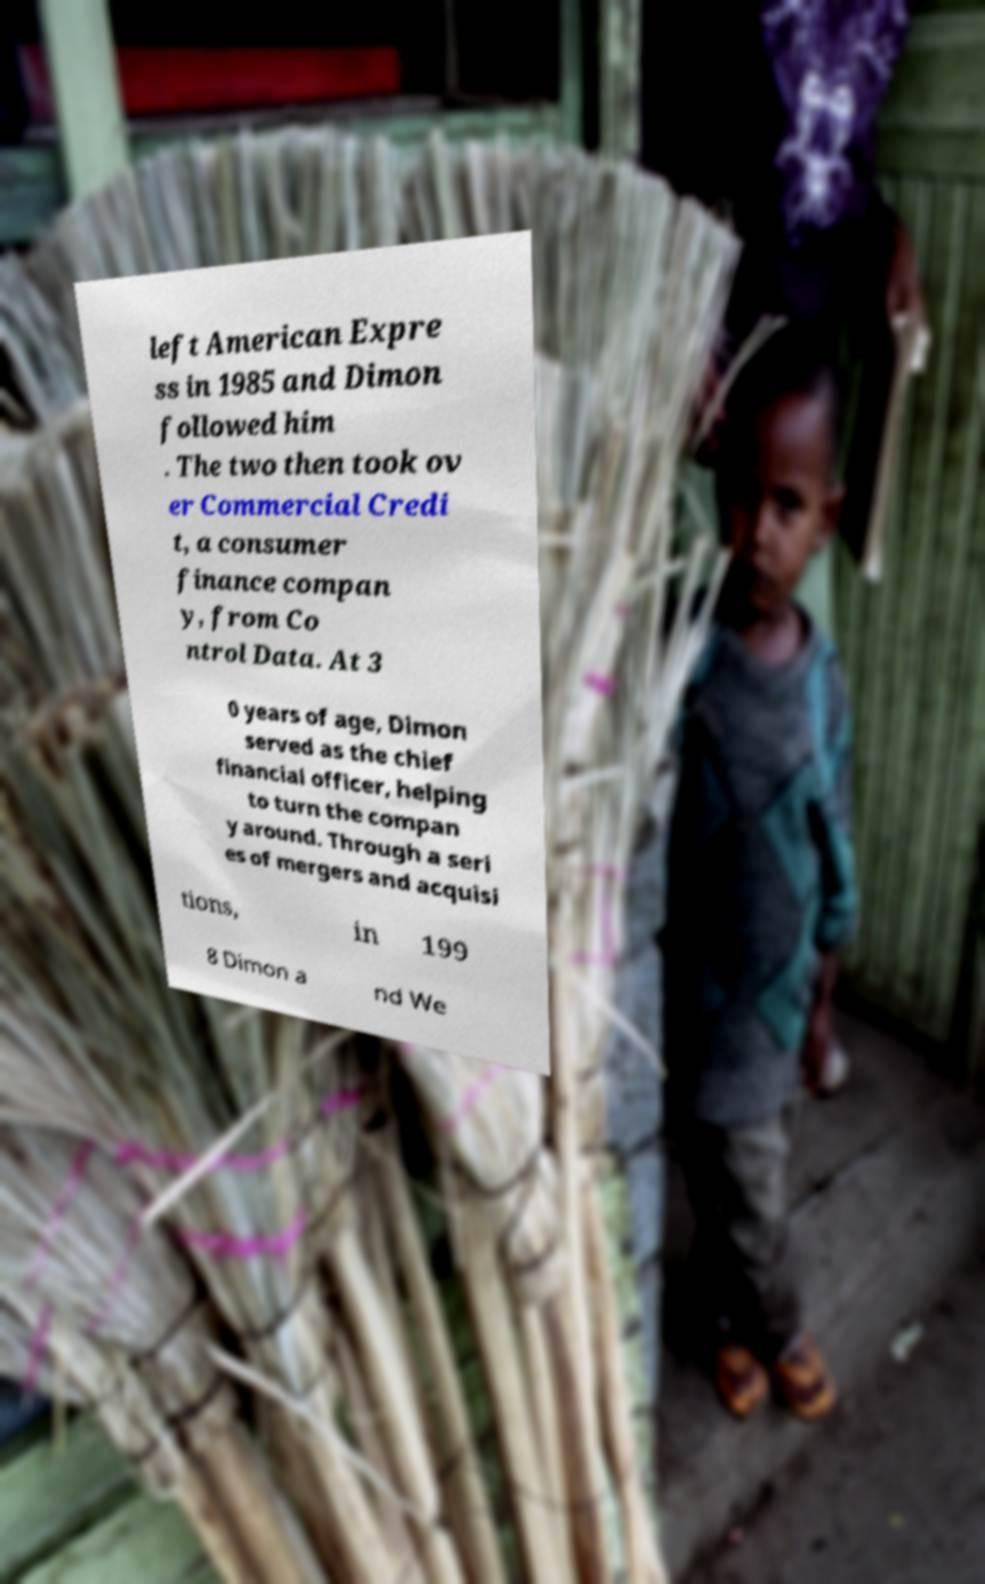Could you assist in decoding the text presented in this image and type it out clearly? left American Expre ss in 1985 and Dimon followed him . The two then took ov er Commercial Credi t, a consumer finance compan y, from Co ntrol Data. At 3 0 years of age, Dimon served as the chief financial officer, helping to turn the compan y around. Through a seri es of mergers and acquisi tions, in 199 8 Dimon a nd We 